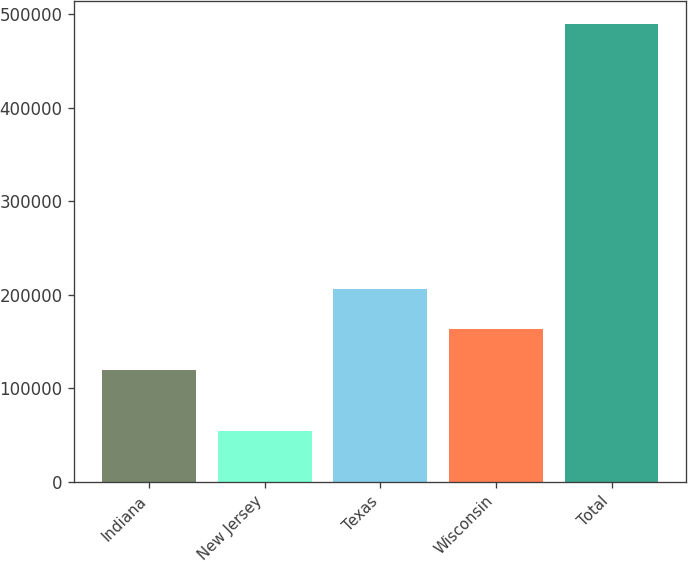Convert chart to OTSL. <chart><loc_0><loc_0><loc_500><loc_500><bar_chart><fcel>Indiana<fcel>New Jersey<fcel>Texas<fcel>Wisconsin<fcel>Total<nl><fcel>119400<fcel>54000<fcel>206520<fcel>162960<fcel>489600<nl></chart> 